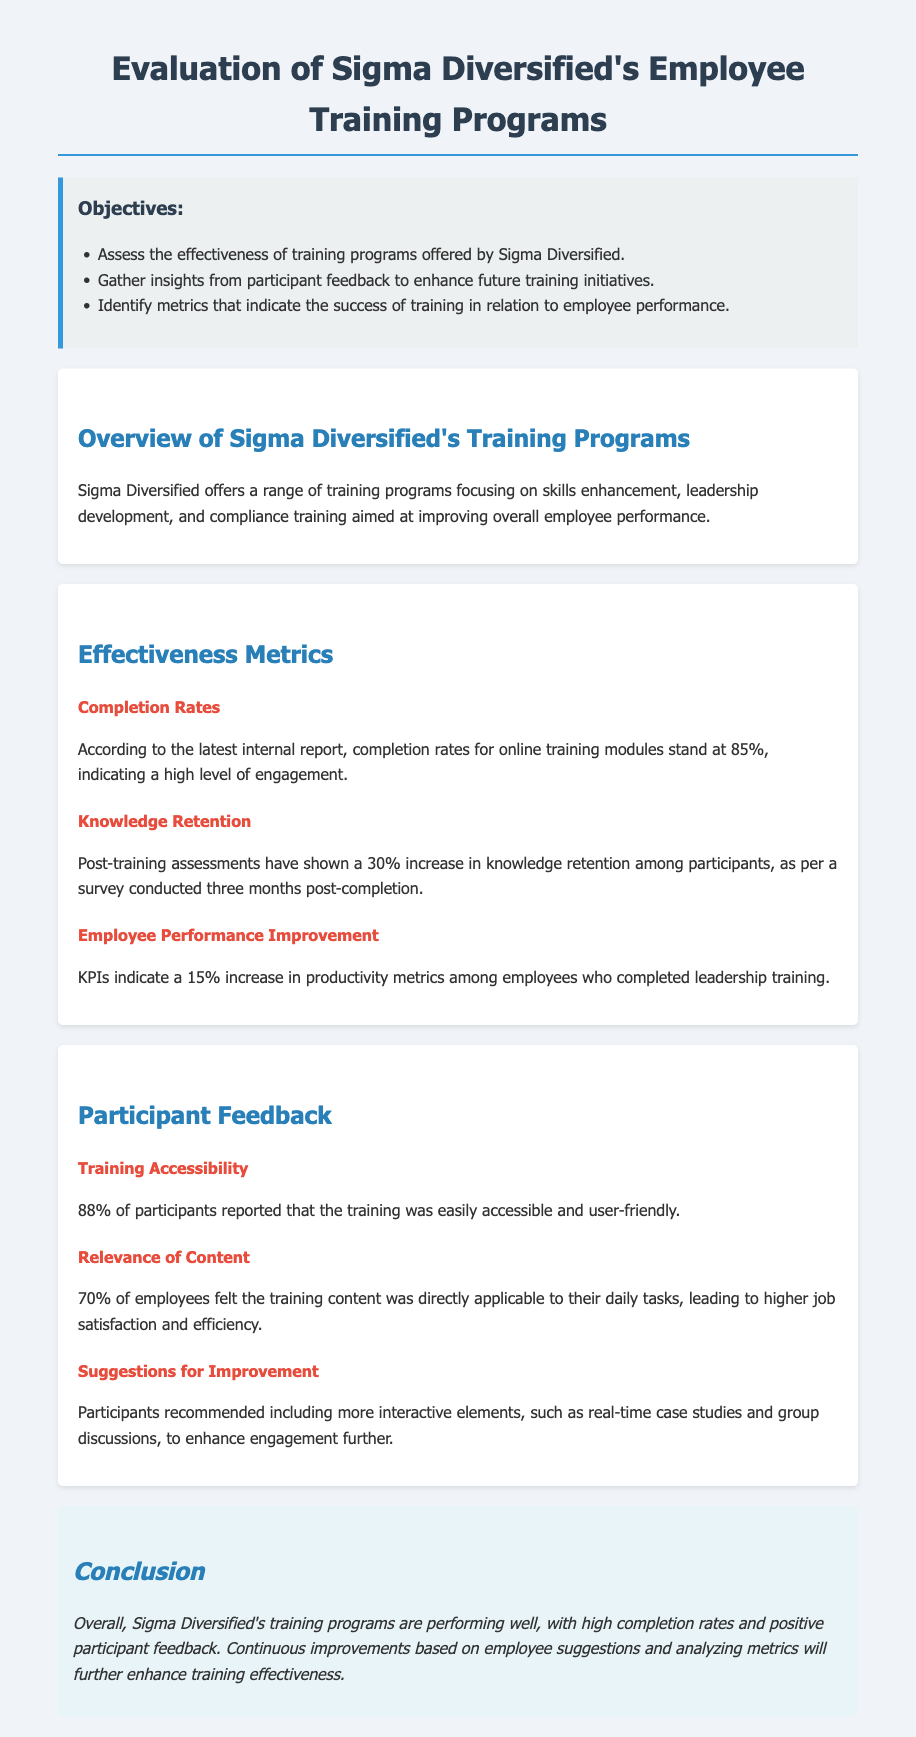What is the completion rate for online training modules? The document states that completion rates for online training modules stand at 85%.
Answer: 85% What percentage of participants found the training easily accessible? According to participant feedback, 88% reported that the training was easily accessible and user-friendly.
Answer: 88% What was the increase in knowledge retention among participants? The document notes a 30% increase in knowledge retention among participants, as per surveys conducted three months post-completion.
Answer: 30% How much improvement in productivity metrics was observed among employees who completed leadership training? KPIs indicate a 15% increase in productivity metrics among employees who completed leadership training.
Answer: 15% What percentage of employees felt the training content was applicable to their daily tasks? The document indicates that 70% of employees felt the training content was directly applicable to their daily tasks.
Answer: 70% What did participants suggest to enhance engagement in training? Participants recommended including more interactive elements, such as real-time case studies and group discussions.
Answer: Interactive elements What is one of the objectives of evaluating Sigma Diversified's training programs? One objective is to gather insights from participant feedback to enhance future training initiatives.
Answer: Gather insights What is the overall performance indication of Sigma Diversified's training programs? The conclusion states that Sigma Diversified's training programs are performing well with high completion rates and positive participant feedback.
Answer: Performing well What is the main focus of Sigma Diversified's training programs? The main focus is on skills enhancement, leadership development, and compliance training.
Answer: Skills enhancement, leadership development, and compliance training 